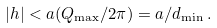Convert formula to latex. <formula><loc_0><loc_0><loc_500><loc_500>| h | < a ( Q _ { \max } / 2 \pi ) = a / d _ { \min } \, .</formula> 